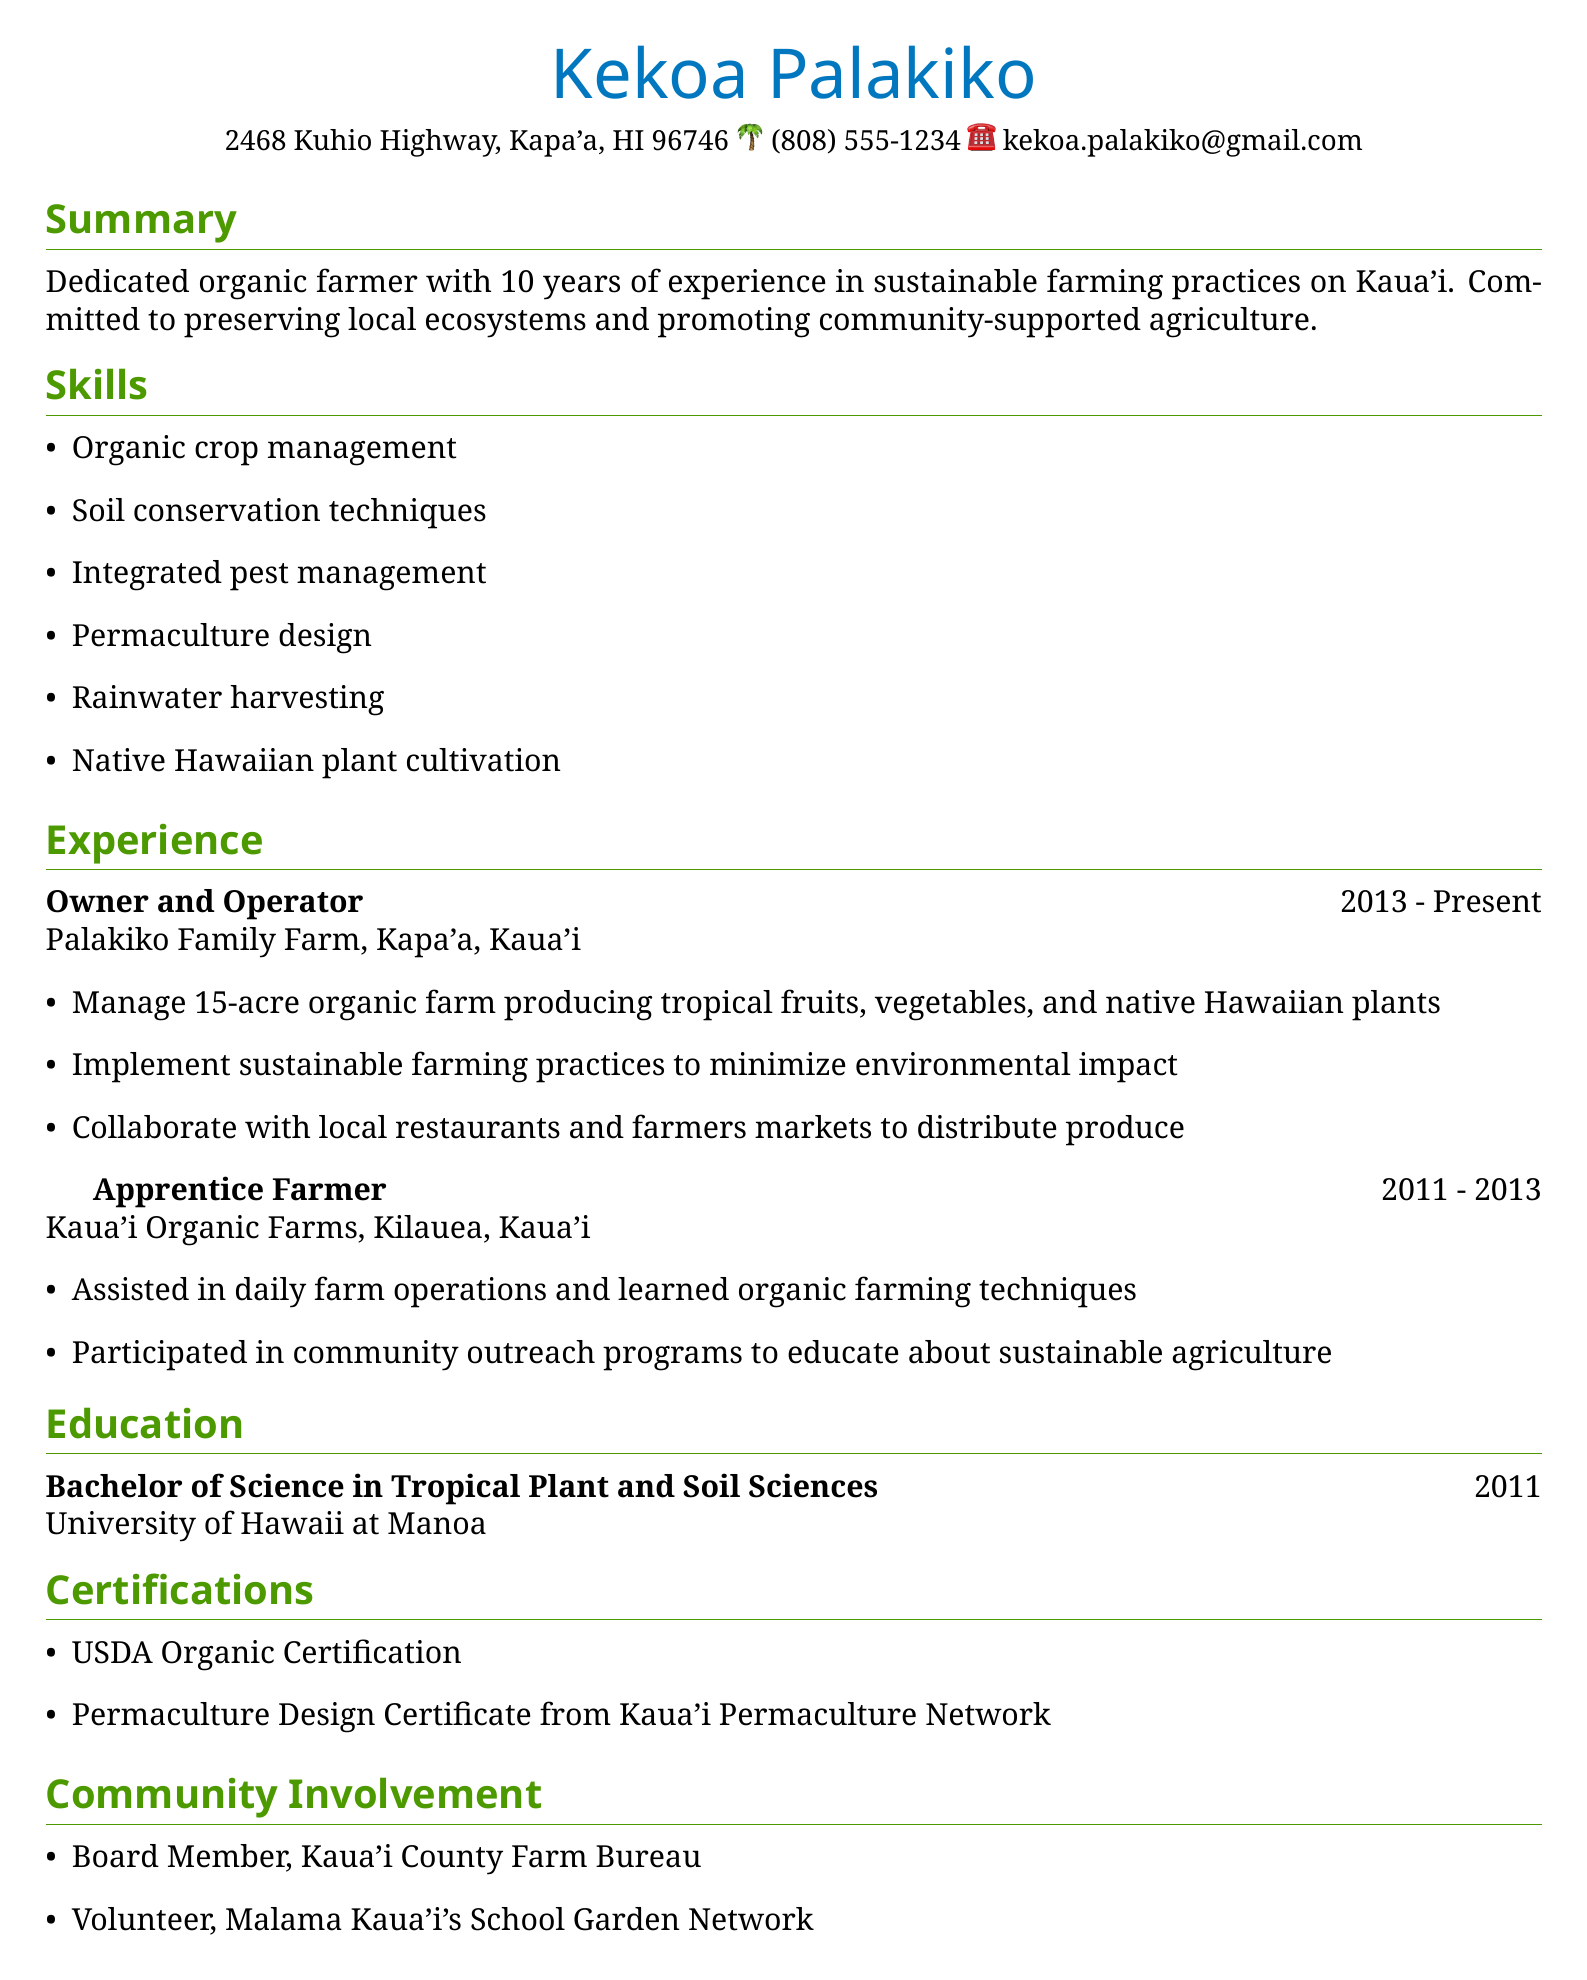what is the name of the individual? The individual's name is provided at the beginning of the document.
Answer: Kekoa Palakiko how many years of experience in farming does the individual have? The summary section states the individual's experience in years.
Answer: 10 years what is the location of the Palakiko Family Farm? The experience section specifies the location of the farm.
Answer: Kapa'a, Kaua'i when did the individual graduate? The education section includes the graduation year.
Answer: 2011 which certification relates to organic farming? The certifications section lists credentials related to organic farming.
Answer: USDA Organic Certification what type of degree does the individual hold? The education section describes the degree attained by the individual.
Answer: Bachelor of Science in Tropical Plant and Soil Sciences name one responsibility of the Owner and Operator role. The experience section outlines various responsibilities; one can be chosen from among them.
Answer: Manage 15-acre organic farm producing tropical fruits, vegetables, and native Hawaiian plants how many acres does the farm cover? This is specifically mentioned in the Owner and Operator responsibilities.
Answer: 15-acre what community role does the individual hold? The community involvement section provides details of the individual's roles in the community.
Answer: Board Member, Kaua'i County Farm Bureau 